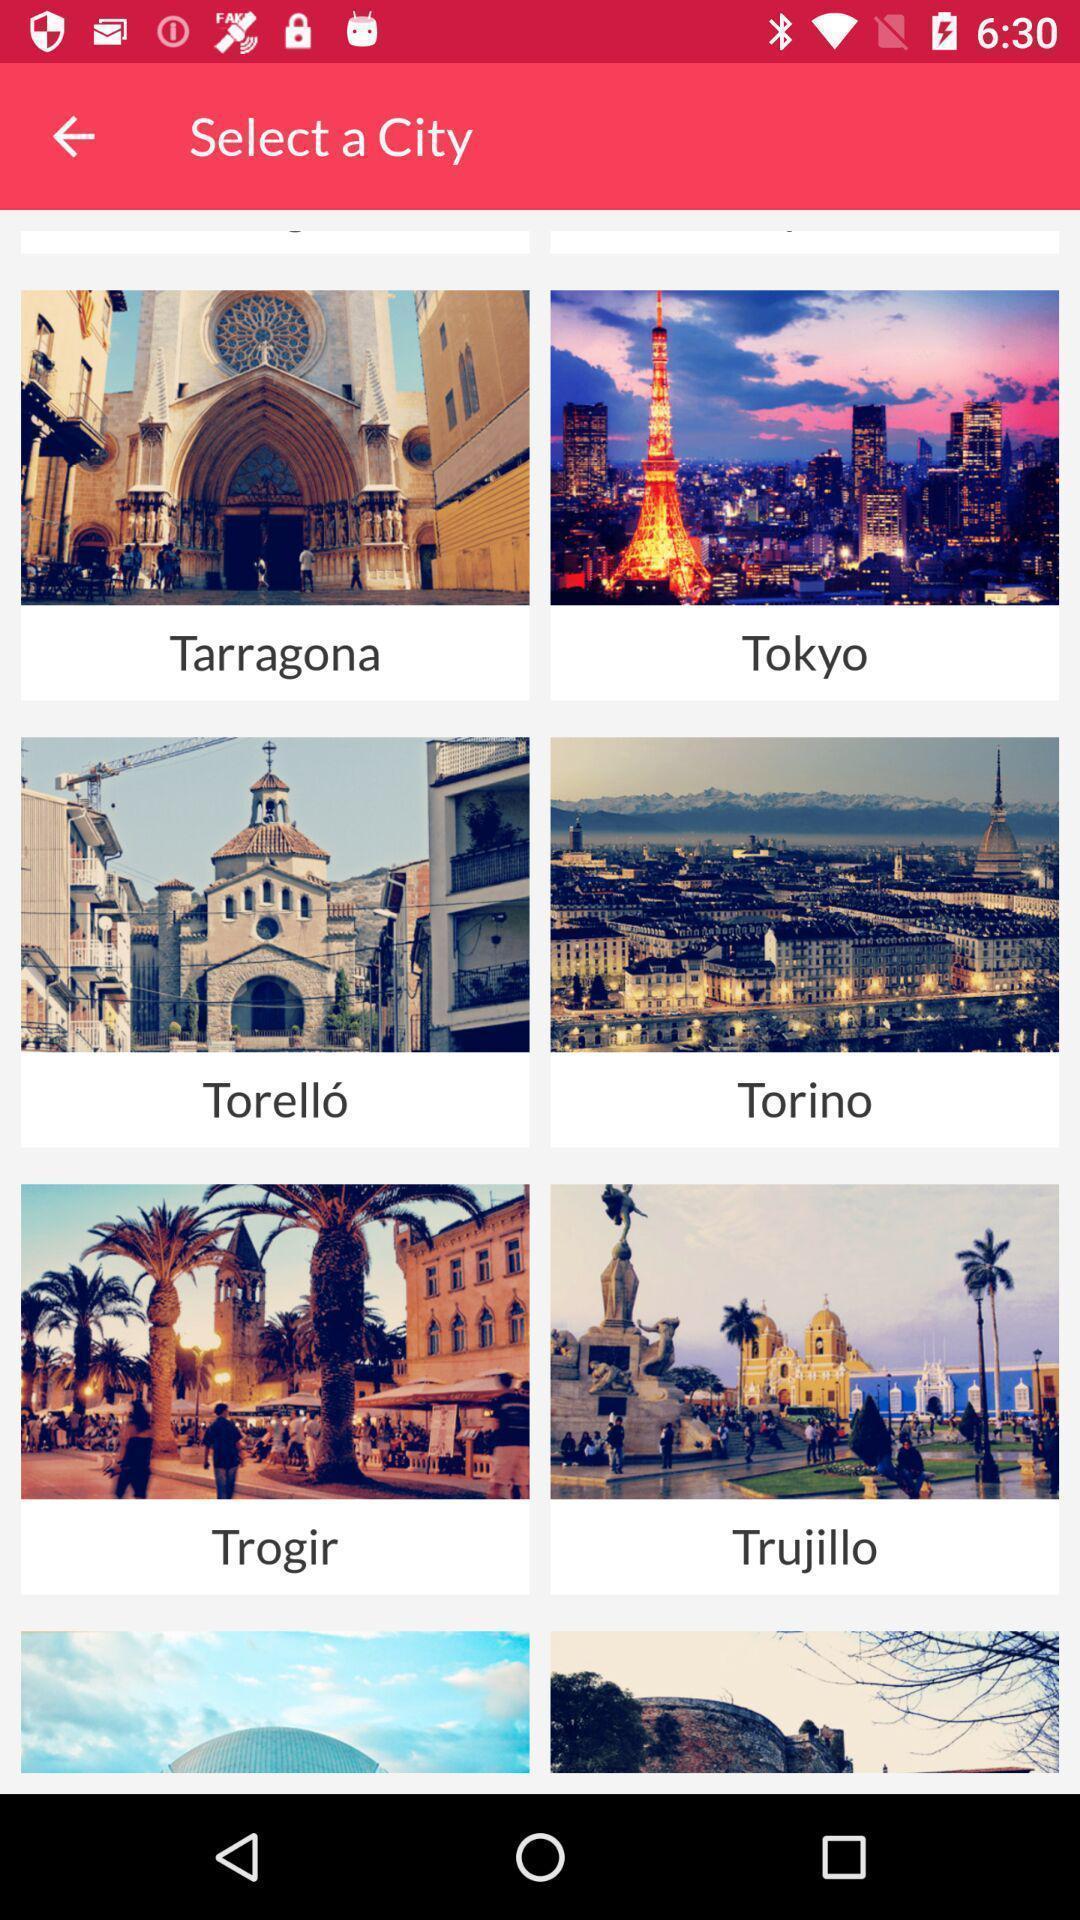Tell me what you see in this picture. Screen showing list of cities. 